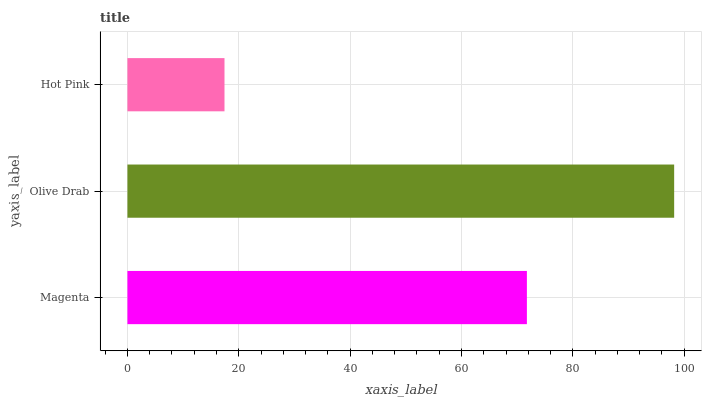Is Hot Pink the minimum?
Answer yes or no. Yes. Is Olive Drab the maximum?
Answer yes or no. Yes. Is Olive Drab the minimum?
Answer yes or no. No. Is Hot Pink the maximum?
Answer yes or no. No. Is Olive Drab greater than Hot Pink?
Answer yes or no. Yes. Is Hot Pink less than Olive Drab?
Answer yes or no. Yes. Is Hot Pink greater than Olive Drab?
Answer yes or no. No. Is Olive Drab less than Hot Pink?
Answer yes or no. No. Is Magenta the high median?
Answer yes or no. Yes. Is Magenta the low median?
Answer yes or no. Yes. Is Hot Pink the high median?
Answer yes or no. No. Is Hot Pink the low median?
Answer yes or no. No. 